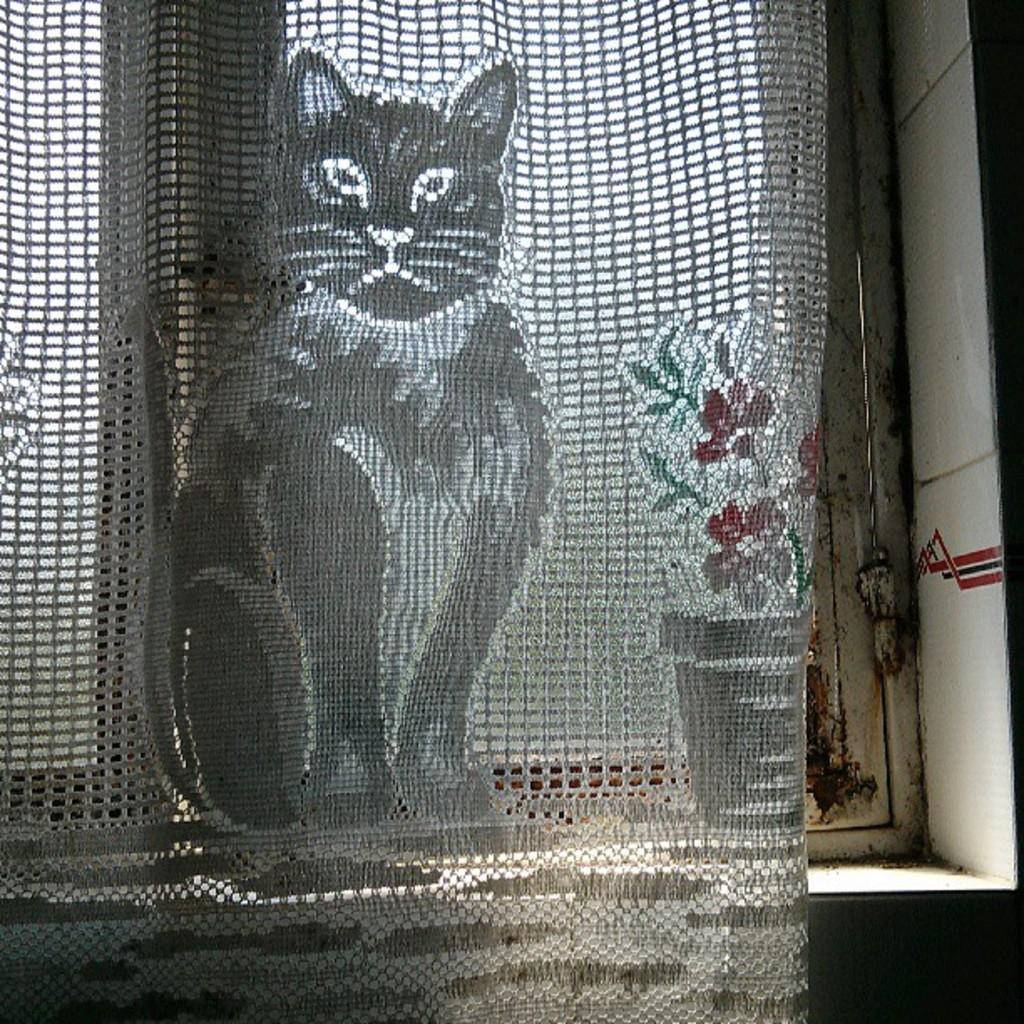Can you describe this image briefly? In this picture there is a grey net window cloth which is hanged near to the window. In that cloth I can see the shape of the cat, flowers and pot. Through the window I can see the sky. 